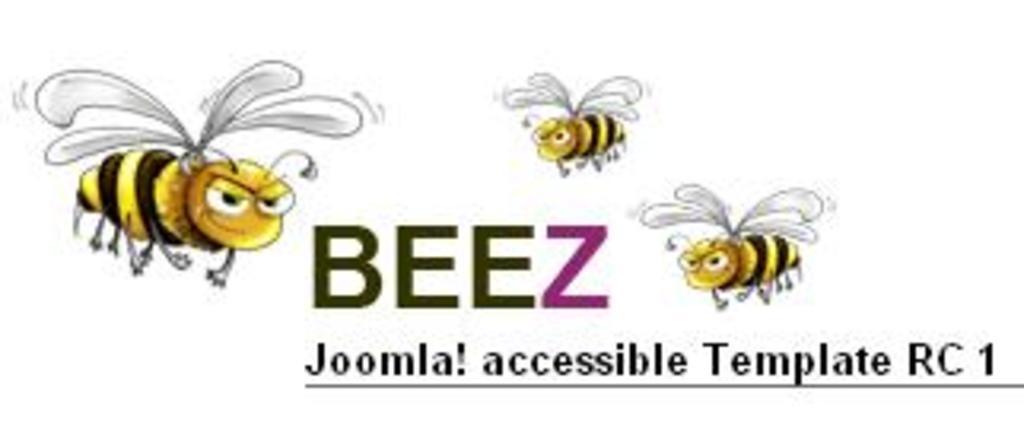In one or two sentences, can you explain what this image depicts? This is an animated image in which there are honey bees and there is some text written on it. 